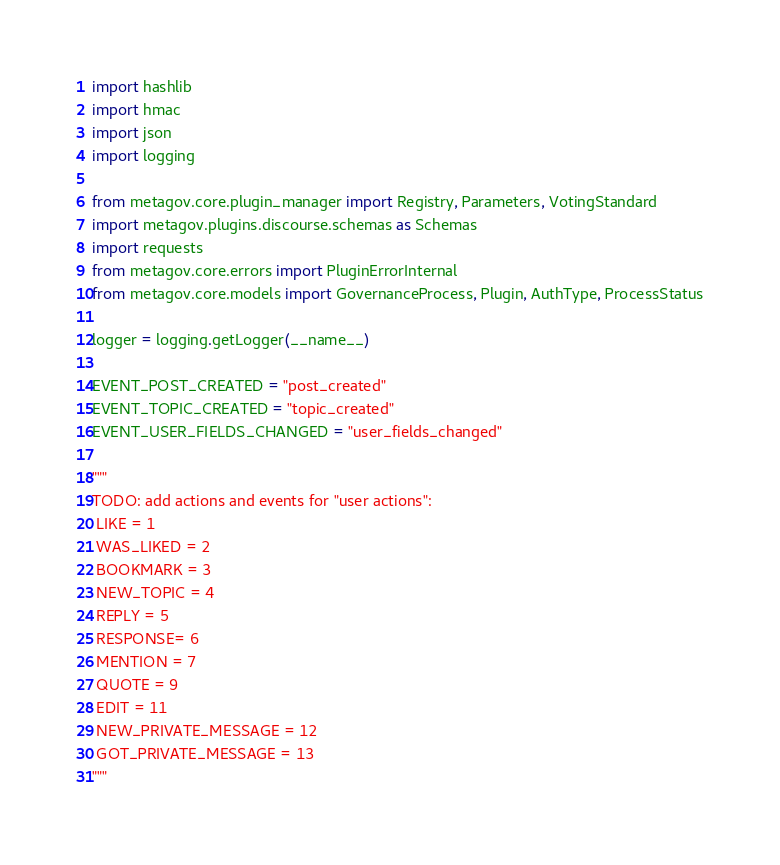Convert code to text. <code><loc_0><loc_0><loc_500><loc_500><_Python_>import hashlib
import hmac
import json
import logging

from metagov.core.plugin_manager import Registry, Parameters, VotingStandard
import metagov.plugins.discourse.schemas as Schemas
import requests
from metagov.core.errors import PluginErrorInternal
from metagov.core.models import GovernanceProcess, Plugin, AuthType, ProcessStatus

logger = logging.getLogger(__name__)

EVENT_POST_CREATED = "post_created"
EVENT_TOPIC_CREATED = "topic_created"
EVENT_USER_FIELDS_CHANGED = "user_fields_changed"

"""
TODO: add actions and events for "user actions":
 LIKE = 1
 WAS_LIKED = 2
 BOOKMARK = 3
 NEW_TOPIC = 4
 REPLY = 5
 RESPONSE= 6
 MENTION = 7
 QUOTE = 9
 EDIT = 11
 NEW_PRIVATE_MESSAGE = 12
 GOT_PRIVATE_MESSAGE = 13
"""

</code> 